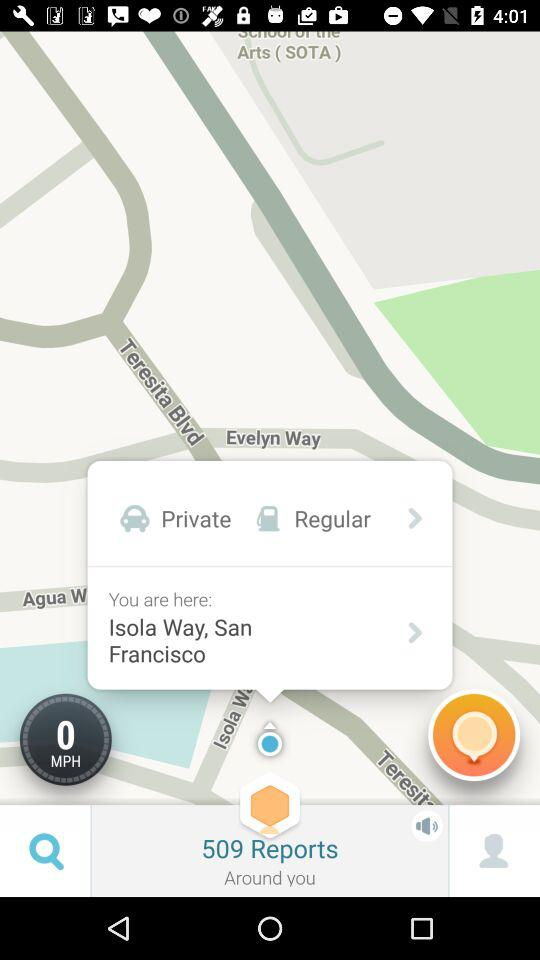What is the speed? The speed is 0 mph. 